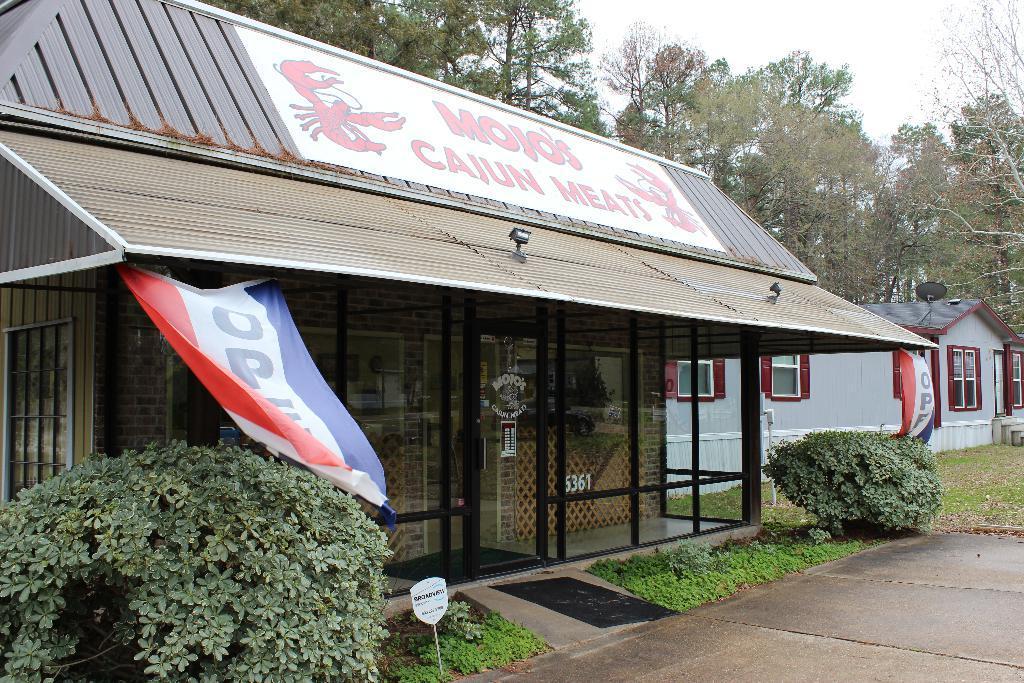Could you give a brief overview of what you see in this image? This picture is taken from outside of the house. In this image, in the left corner, we can see some plants, board. On the right side, we can see some plants, house, glass window. In the middle of the image, we can see a hoarding, glass door, building. In the background, we can see some trees, plants. At the top, we can see a sky, at the bottom, we can see a grass and a mat. 